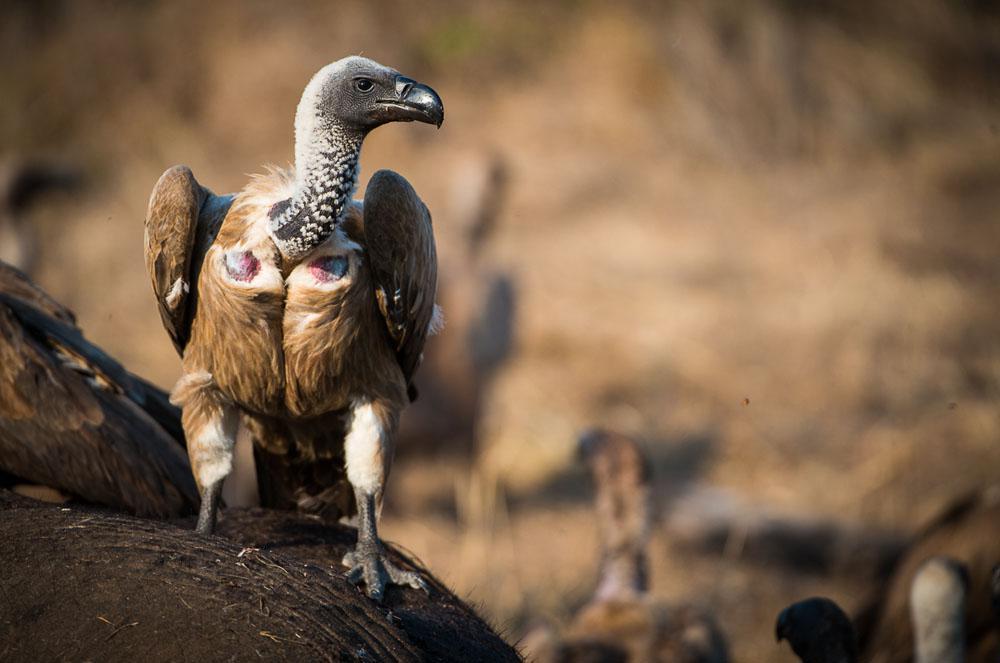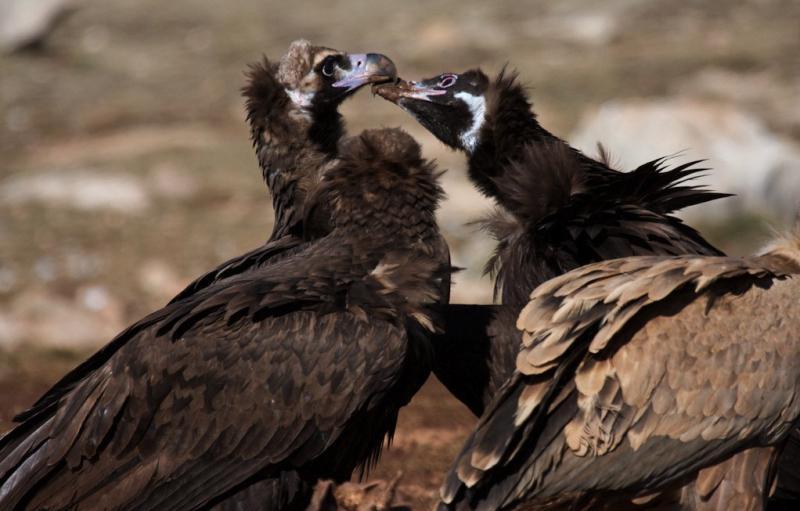The first image is the image on the left, the second image is the image on the right. Assess this claim about the two images: "The left image shows one foreground vulture, which stands on a carcass with its head facing right.". Correct or not? Answer yes or no. Yes. The first image is the image on the left, the second image is the image on the right. For the images displayed, is the sentence "A vulture has its wings spread, as it confronts another vulture" factually correct? Answer yes or no. No. 